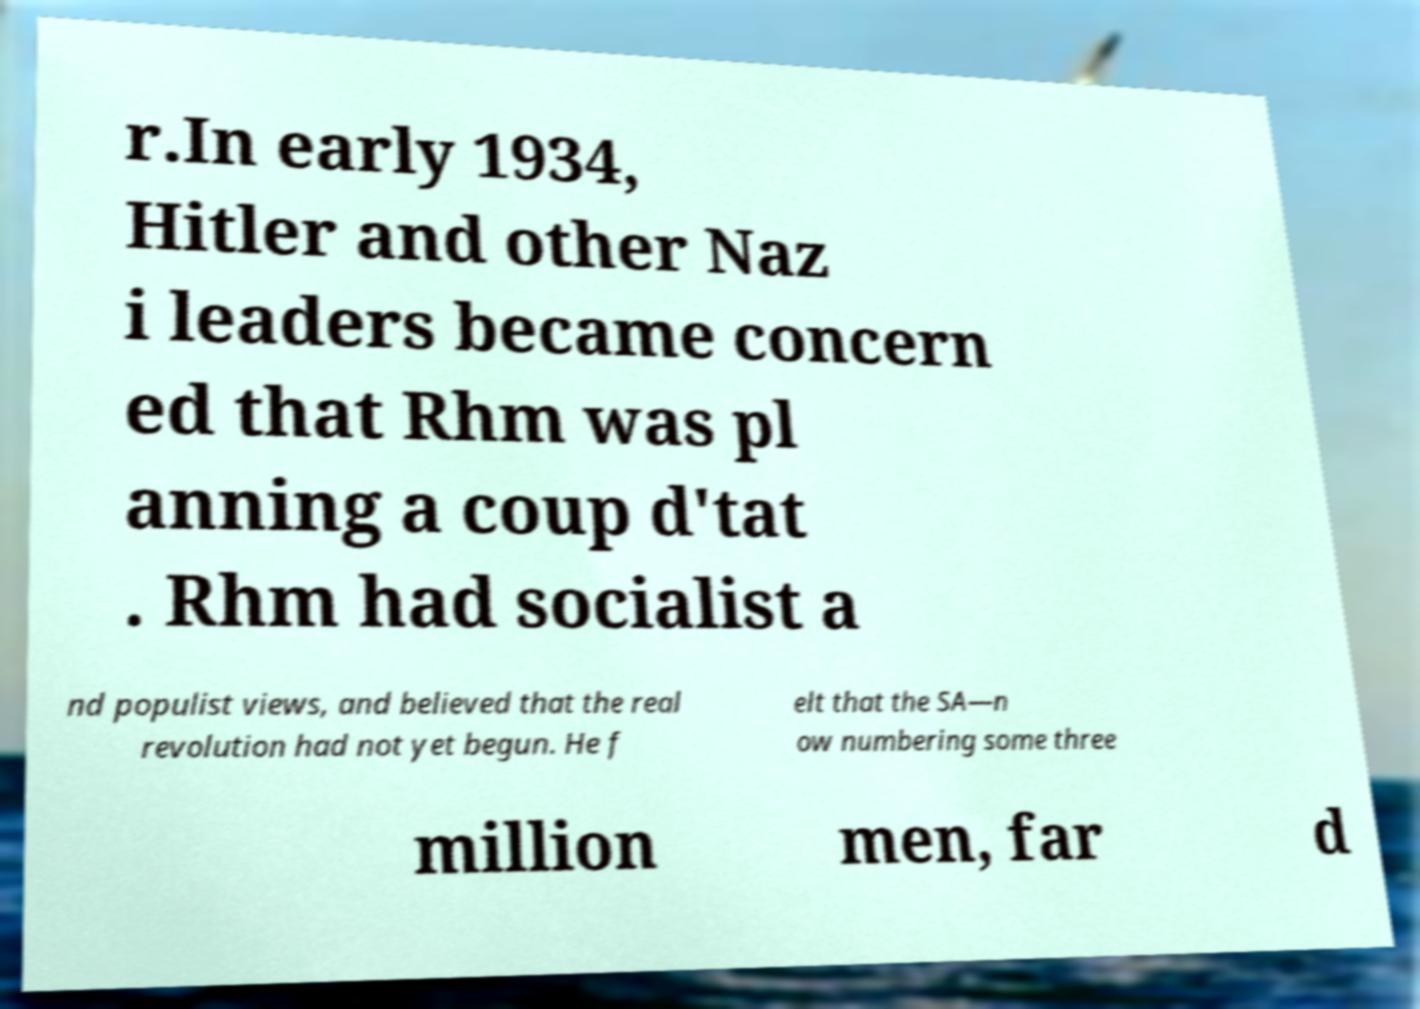There's text embedded in this image that I need extracted. Can you transcribe it verbatim? r.In early 1934, Hitler and other Naz i leaders became concern ed that Rhm was pl anning a coup d'tat . Rhm had socialist a nd populist views, and believed that the real revolution had not yet begun. He f elt that the SA—n ow numbering some three million men, far d 